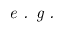Convert formula to latex. <formula><loc_0><loc_0><loc_500><loc_500>e . g .</formula> 